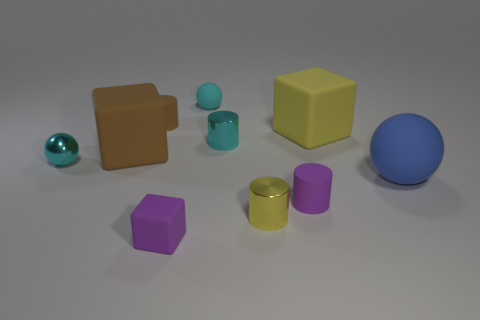Subtract 1 spheres. How many spheres are left? 2 Subtract all purple cylinders. How many cylinders are left? 3 Subtract all cyan balls. How many balls are left? 1 Subtract all blue cylinders. Subtract all red cubes. How many cylinders are left? 4 Subtract all cylinders. How many objects are left? 6 Add 9 shiny balls. How many shiny balls are left? 10 Add 5 tiny brown rubber cylinders. How many tiny brown rubber cylinders exist? 6 Subtract 0 gray cylinders. How many objects are left? 10 Subtract all small brown cylinders. Subtract all blue rubber objects. How many objects are left? 8 